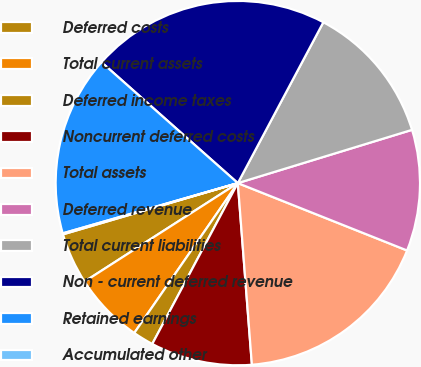<chart> <loc_0><loc_0><loc_500><loc_500><pie_chart><fcel>Deferred costs<fcel>Total current assets<fcel>Deferred income taxes<fcel>Noncurrent deferred costs<fcel>Total assets<fcel>Deferred revenue<fcel>Total current liabilities<fcel>Non - current deferred revenue<fcel>Retained earnings<fcel>Accumulated other<nl><fcel>4.55%<fcel>6.29%<fcel>1.84%<fcel>9.01%<fcel>17.74%<fcel>10.75%<fcel>12.5%<fcel>21.23%<fcel>15.99%<fcel>0.09%<nl></chart> 